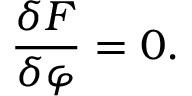Convert formula to latex. <formula><loc_0><loc_0><loc_500><loc_500>\frac { \delta F } { \delta \varphi } = 0 .</formula> 